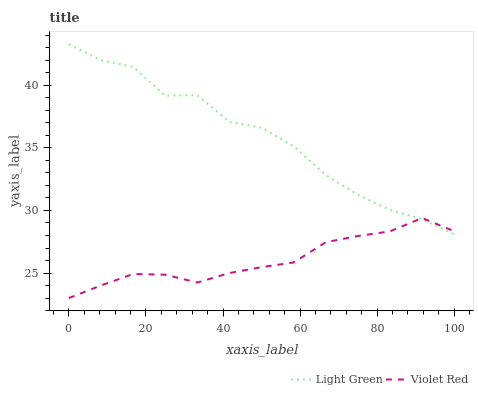Does Violet Red have the minimum area under the curve?
Answer yes or no. Yes. Does Light Green have the maximum area under the curve?
Answer yes or no. Yes. Does Light Green have the minimum area under the curve?
Answer yes or no. No. Is Violet Red the smoothest?
Answer yes or no. Yes. Is Light Green the roughest?
Answer yes or no. Yes. Is Light Green the smoothest?
Answer yes or no. No. Does Violet Red have the lowest value?
Answer yes or no. Yes. Does Light Green have the lowest value?
Answer yes or no. No. Does Light Green have the highest value?
Answer yes or no. Yes. Does Light Green intersect Violet Red?
Answer yes or no. Yes. Is Light Green less than Violet Red?
Answer yes or no. No. Is Light Green greater than Violet Red?
Answer yes or no. No. 